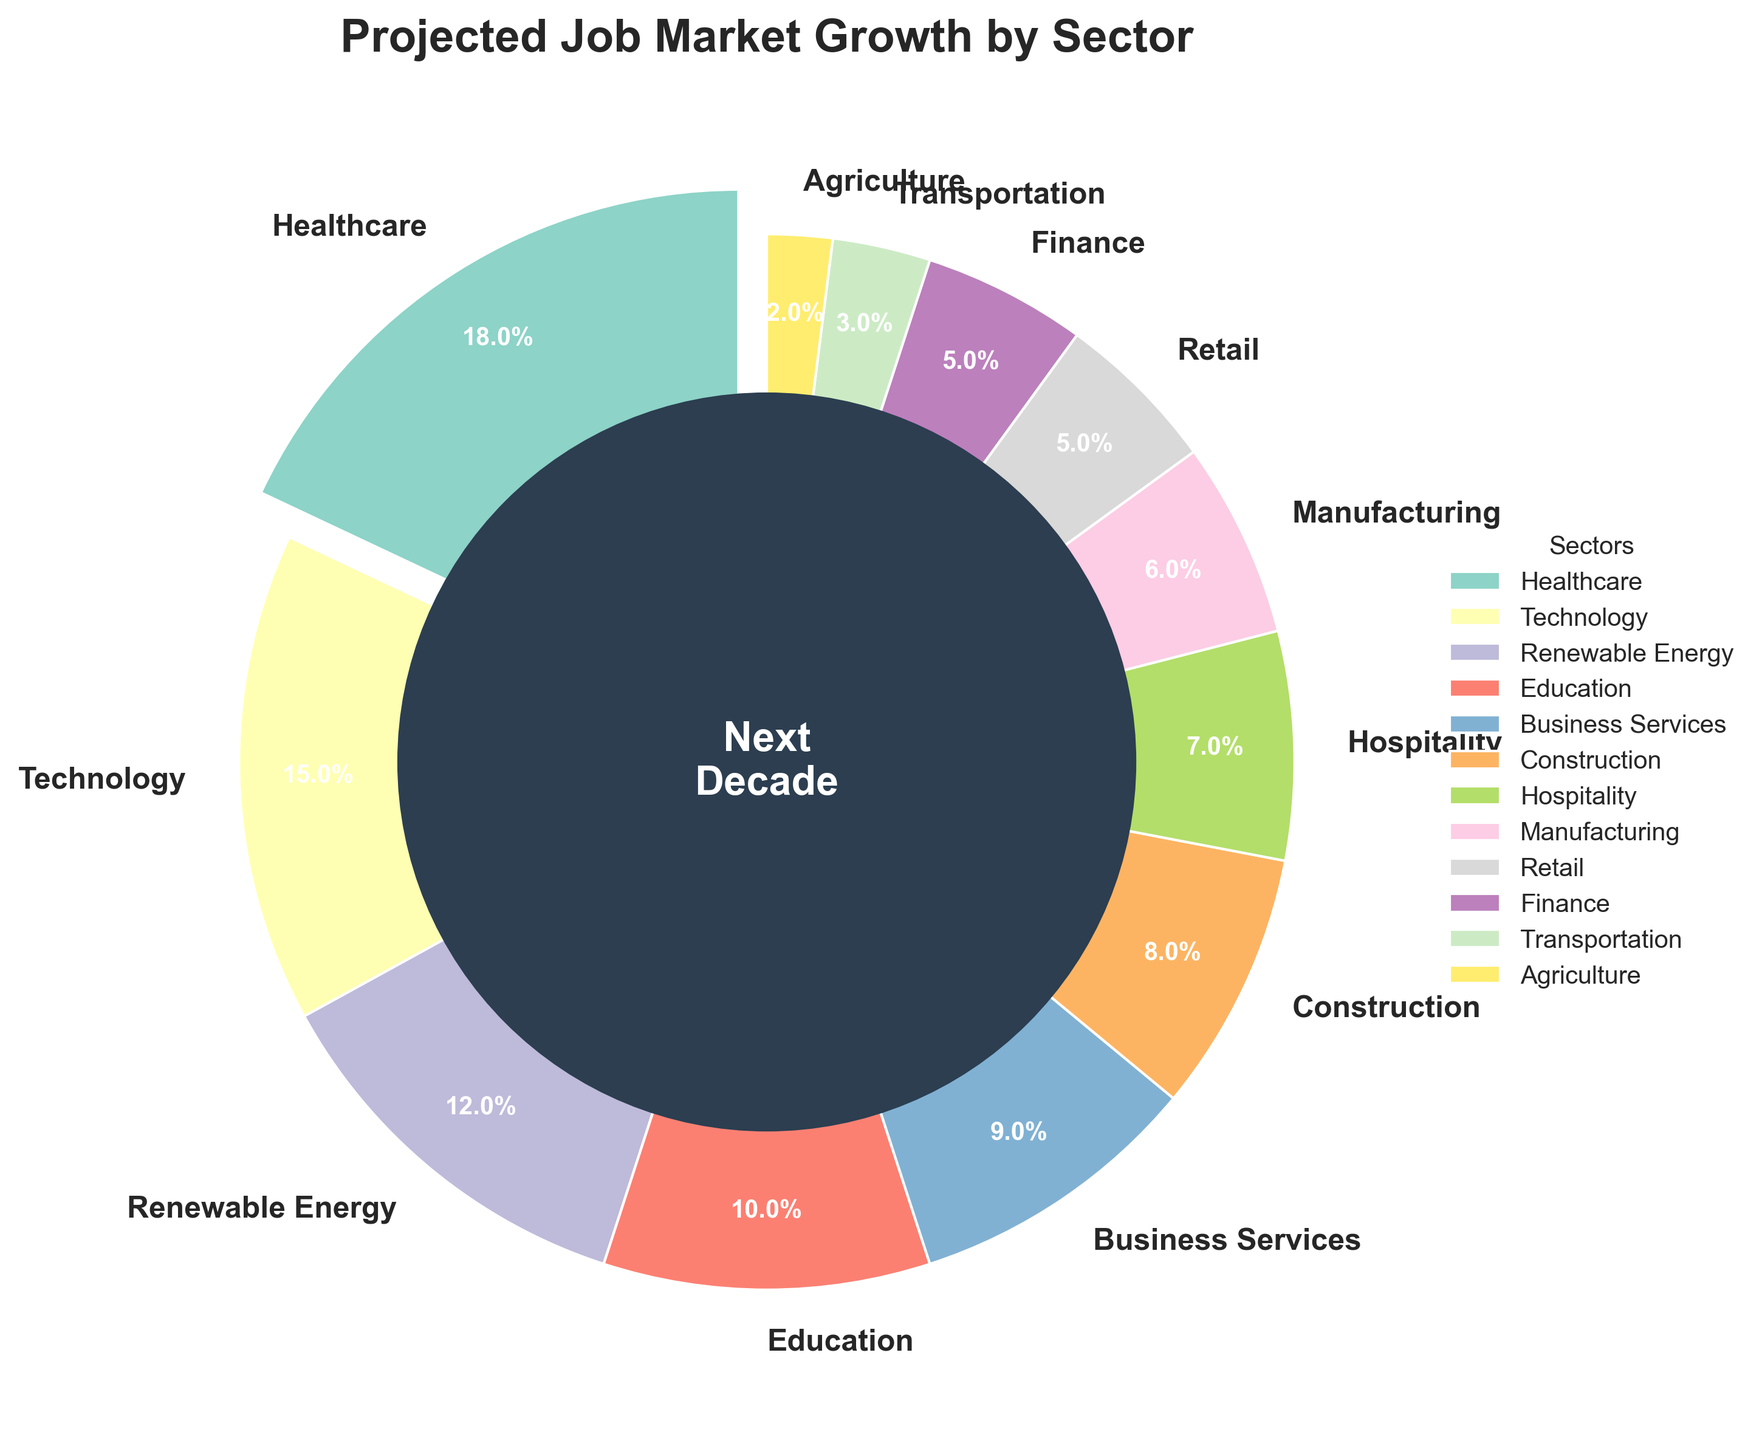What sector is projected to have the highest job market growth in the next decade? The sector with the largest wedge in the pie chart and the one that is slightly exploded out is Healthcare, indicating it has the highest projected job market growth percentage.
Answer: Healthcare Which sectors have the same projected growth percentage? Looking at the labels around the pie chart, both Retail and Finance sectors have wedges that show a 5% growth projection.
Answer: Retail and Finance How much more job market growth is projected for Healthcare compared to Transportation? Healthcare has an 18% growth, and Transportation has a 3% growth. The difference between them is calculated as 18% - 3%.
Answer: 15% If you combine the projected growth percentages of Technology and Renewable Energy, what is the total? The projected growth for Technology is 15%, and for Renewable Energy is 12%. Adding them together gives 15% + 12%.
Answer: 27% How does the projected growth for Construction compare to Education? Construction has a projected growth of 8%, whereas Education has 10%. Since 10% is greater than 8%, Education has a higher growth projection.
Answer: Education has more growth Which sector's wedge uses green in the color scheme? The pie chart uses different colors for each sector, and Technology's wedge is represented with a green color.
Answer: Technology Considering the projected percentages, what is the average growth for the sectors Hospitality and Business Services? Hospitality has a 7% projected growth, and Business Services have 9%. The average is calculated as (7% + 9%) / 2.
Answer: 8% If you sum up the growth projections for Agriculture, Transportation, and Retail, does it exceed 10%? Agriculture has a 2% growth, Transportation has 3%, and Retail has 5%. Summing them: 2% + 3% + 5% = 10%.
Answer: No What is the projected growth for all sectors combined? Adding up all the individual sector percentages provided: 18% + 15% + 12% + 10% + 9% + 8% + 7% + 6% + 5% + 5% + 3% + 2% = 100%.
Answer: 100% By how much does the projected growth for Business Services fall short compared to Healthcare? Healthcare has an 18% growth projection, while Business Services have 9%. The shortfall is 18% - 9%.
Answer: 9% 